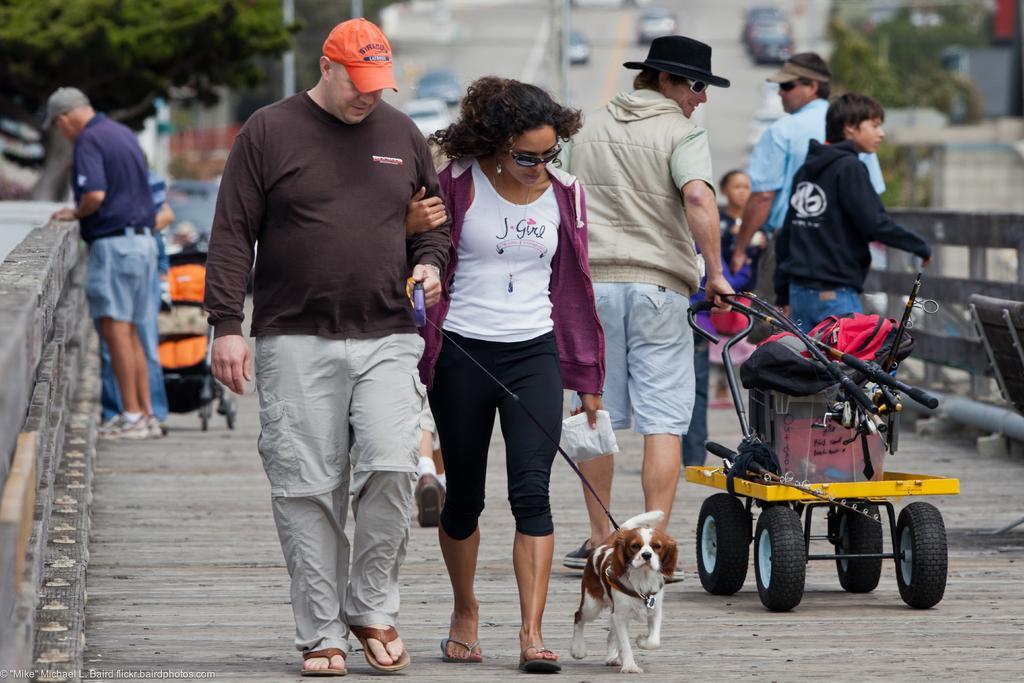Please provide a concise description of this image. In this picture I can see group of people standing on the bridge, there is a dog, stroller, and in the background there are vehicles on the road and there are trees. 